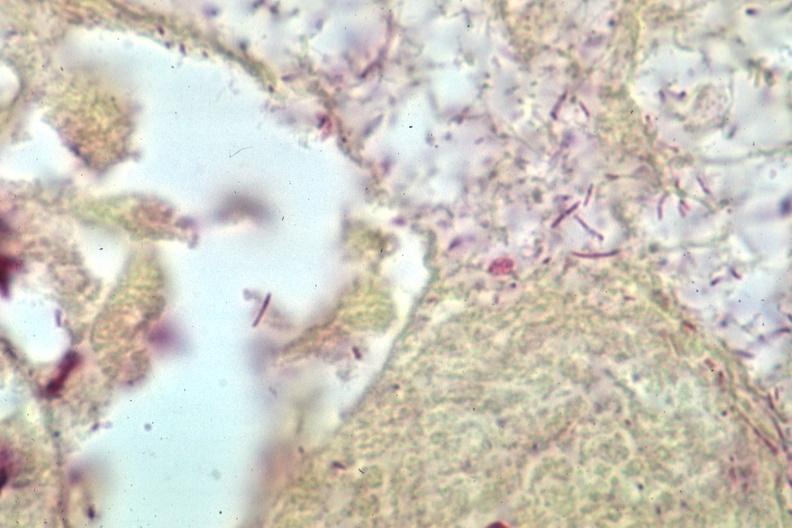what is present?
Answer the question using a single word or phrase. Brain 